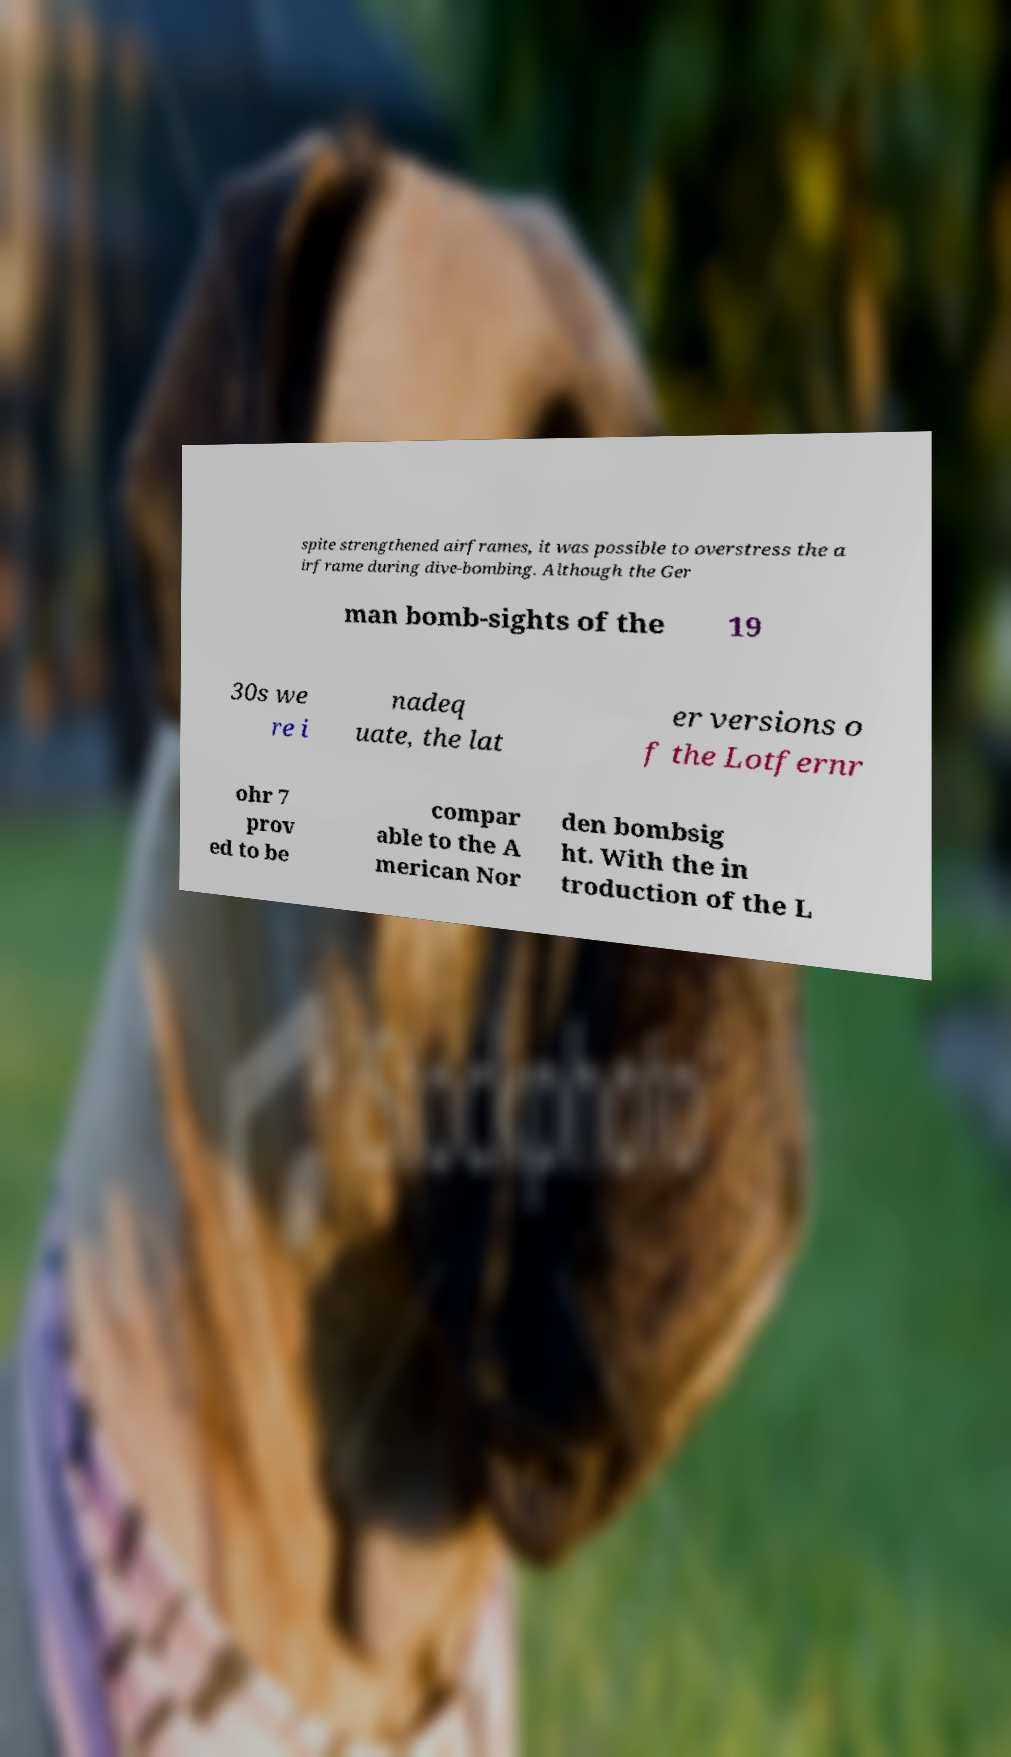Can you accurately transcribe the text from the provided image for me? spite strengthened airframes, it was possible to overstress the a irframe during dive-bombing. Although the Ger man bomb-sights of the 19 30s we re i nadeq uate, the lat er versions o f the Lotfernr ohr 7 prov ed to be compar able to the A merican Nor den bombsig ht. With the in troduction of the L 